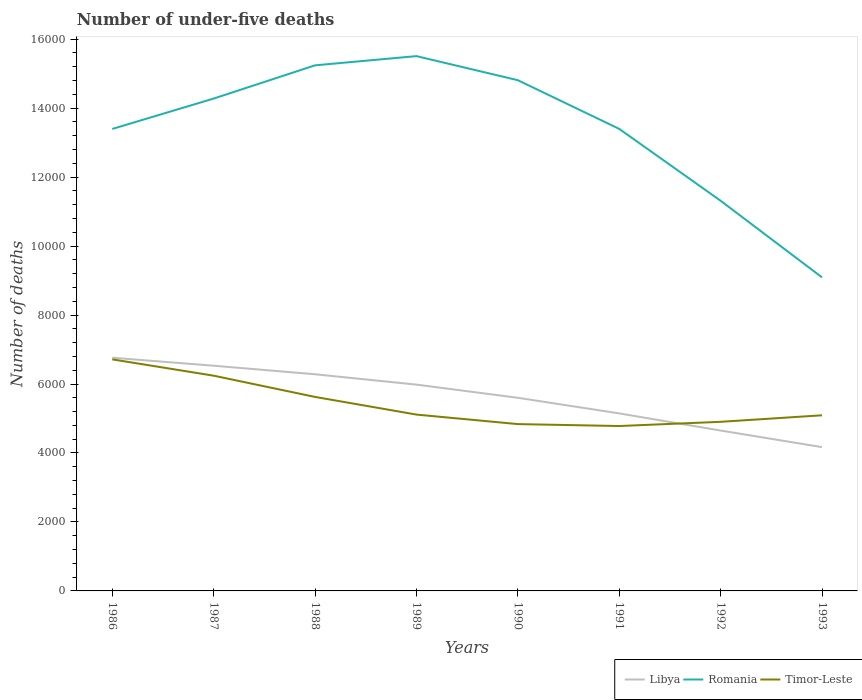Is the number of lines equal to the number of legend labels?
Your response must be concise. Yes. Across all years, what is the maximum number of under-five deaths in Timor-Leste?
Your response must be concise. 4782. What is the total number of under-five deaths in Romania in the graph?
Your response must be concise. 1843. What is the difference between the highest and the second highest number of under-five deaths in Timor-Leste?
Keep it short and to the point. 1933. What is the difference between the highest and the lowest number of under-five deaths in Libya?
Your answer should be very brief. 4. Is the number of under-five deaths in Timor-Leste strictly greater than the number of under-five deaths in Libya over the years?
Keep it short and to the point. No. How many lines are there?
Offer a terse response. 3. Are the values on the major ticks of Y-axis written in scientific E-notation?
Keep it short and to the point. No. Does the graph contain grids?
Your answer should be compact. No. How many legend labels are there?
Offer a terse response. 3. How are the legend labels stacked?
Offer a terse response. Horizontal. What is the title of the graph?
Give a very brief answer. Number of under-five deaths. Does "France" appear as one of the legend labels in the graph?
Keep it short and to the point. No. What is the label or title of the X-axis?
Ensure brevity in your answer.  Years. What is the label or title of the Y-axis?
Give a very brief answer. Number of deaths. What is the Number of deaths in Libya in 1986?
Make the answer very short. 6763. What is the Number of deaths of Romania in 1986?
Your response must be concise. 1.34e+04. What is the Number of deaths in Timor-Leste in 1986?
Provide a short and direct response. 6715. What is the Number of deaths in Libya in 1987?
Offer a terse response. 6531. What is the Number of deaths of Romania in 1987?
Your answer should be compact. 1.43e+04. What is the Number of deaths of Timor-Leste in 1987?
Provide a succinct answer. 6242. What is the Number of deaths in Libya in 1988?
Give a very brief answer. 6283. What is the Number of deaths of Romania in 1988?
Make the answer very short. 1.52e+04. What is the Number of deaths of Timor-Leste in 1988?
Ensure brevity in your answer.  5626. What is the Number of deaths in Libya in 1989?
Offer a terse response. 5983. What is the Number of deaths of Romania in 1989?
Provide a succinct answer. 1.55e+04. What is the Number of deaths of Timor-Leste in 1989?
Offer a very short reply. 5114. What is the Number of deaths in Libya in 1990?
Offer a terse response. 5601. What is the Number of deaths of Romania in 1990?
Keep it short and to the point. 1.48e+04. What is the Number of deaths in Timor-Leste in 1990?
Offer a very short reply. 4838. What is the Number of deaths of Libya in 1991?
Ensure brevity in your answer.  5148. What is the Number of deaths of Romania in 1991?
Ensure brevity in your answer.  1.34e+04. What is the Number of deaths of Timor-Leste in 1991?
Keep it short and to the point. 4782. What is the Number of deaths of Libya in 1992?
Provide a succinct answer. 4651. What is the Number of deaths of Romania in 1992?
Offer a very short reply. 1.13e+04. What is the Number of deaths of Timor-Leste in 1992?
Keep it short and to the point. 4904. What is the Number of deaths of Libya in 1993?
Your answer should be compact. 4170. What is the Number of deaths in Romania in 1993?
Your answer should be very brief. 9093. What is the Number of deaths of Timor-Leste in 1993?
Make the answer very short. 5093. Across all years, what is the maximum Number of deaths of Libya?
Keep it short and to the point. 6763. Across all years, what is the maximum Number of deaths in Romania?
Give a very brief answer. 1.55e+04. Across all years, what is the maximum Number of deaths of Timor-Leste?
Your answer should be compact. 6715. Across all years, what is the minimum Number of deaths of Libya?
Make the answer very short. 4170. Across all years, what is the minimum Number of deaths of Romania?
Your response must be concise. 9093. Across all years, what is the minimum Number of deaths in Timor-Leste?
Offer a very short reply. 4782. What is the total Number of deaths of Libya in the graph?
Offer a terse response. 4.51e+04. What is the total Number of deaths in Romania in the graph?
Ensure brevity in your answer.  1.07e+05. What is the total Number of deaths of Timor-Leste in the graph?
Your response must be concise. 4.33e+04. What is the difference between the Number of deaths in Libya in 1986 and that in 1987?
Your answer should be compact. 232. What is the difference between the Number of deaths of Romania in 1986 and that in 1987?
Make the answer very short. -881. What is the difference between the Number of deaths of Timor-Leste in 1986 and that in 1987?
Your answer should be compact. 473. What is the difference between the Number of deaths in Libya in 1986 and that in 1988?
Provide a short and direct response. 480. What is the difference between the Number of deaths in Romania in 1986 and that in 1988?
Make the answer very short. -1845. What is the difference between the Number of deaths in Timor-Leste in 1986 and that in 1988?
Provide a short and direct response. 1089. What is the difference between the Number of deaths in Libya in 1986 and that in 1989?
Give a very brief answer. 780. What is the difference between the Number of deaths in Romania in 1986 and that in 1989?
Ensure brevity in your answer.  -2112. What is the difference between the Number of deaths of Timor-Leste in 1986 and that in 1989?
Provide a short and direct response. 1601. What is the difference between the Number of deaths in Libya in 1986 and that in 1990?
Make the answer very short. 1162. What is the difference between the Number of deaths of Romania in 1986 and that in 1990?
Offer a terse response. -1414. What is the difference between the Number of deaths in Timor-Leste in 1986 and that in 1990?
Provide a succinct answer. 1877. What is the difference between the Number of deaths in Libya in 1986 and that in 1991?
Keep it short and to the point. 1615. What is the difference between the Number of deaths in Romania in 1986 and that in 1991?
Provide a succinct answer. -2. What is the difference between the Number of deaths of Timor-Leste in 1986 and that in 1991?
Ensure brevity in your answer.  1933. What is the difference between the Number of deaths of Libya in 1986 and that in 1992?
Keep it short and to the point. 2112. What is the difference between the Number of deaths of Romania in 1986 and that in 1992?
Provide a succinct answer. 2082. What is the difference between the Number of deaths in Timor-Leste in 1986 and that in 1992?
Your answer should be compact. 1811. What is the difference between the Number of deaths of Libya in 1986 and that in 1993?
Provide a succinct answer. 2593. What is the difference between the Number of deaths in Romania in 1986 and that in 1993?
Your answer should be compact. 4304. What is the difference between the Number of deaths in Timor-Leste in 1986 and that in 1993?
Keep it short and to the point. 1622. What is the difference between the Number of deaths of Libya in 1987 and that in 1988?
Your answer should be compact. 248. What is the difference between the Number of deaths in Romania in 1987 and that in 1988?
Your answer should be very brief. -964. What is the difference between the Number of deaths in Timor-Leste in 1987 and that in 1988?
Your response must be concise. 616. What is the difference between the Number of deaths of Libya in 1987 and that in 1989?
Offer a very short reply. 548. What is the difference between the Number of deaths of Romania in 1987 and that in 1989?
Provide a short and direct response. -1231. What is the difference between the Number of deaths of Timor-Leste in 1987 and that in 1989?
Offer a terse response. 1128. What is the difference between the Number of deaths of Libya in 1987 and that in 1990?
Your answer should be very brief. 930. What is the difference between the Number of deaths of Romania in 1987 and that in 1990?
Ensure brevity in your answer.  -533. What is the difference between the Number of deaths in Timor-Leste in 1987 and that in 1990?
Ensure brevity in your answer.  1404. What is the difference between the Number of deaths of Libya in 1987 and that in 1991?
Provide a succinct answer. 1383. What is the difference between the Number of deaths of Romania in 1987 and that in 1991?
Make the answer very short. 879. What is the difference between the Number of deaths in Timor-Leste in 1987 and that in 1991?
Give a very brief answer. 1460. What is the difference between the Number of deaths of Libya in 1987 and that in 1992?
Your answer should be compact. 1880. What is the difference between the Number of deaths of Romania in 1987 and that in 1992?
Your answer should be very brief. 2963. What is the difference between the Number of deaths of Timor-Leste in 1987 and that in 1992?
Offer a terse response. 1338. What is the difference between the Number of deaths in Libya in 1987 and that in 1993?
Provide a succinct answer. 2361. What is the difference between the Number of deaths in Romania in 1987 and that in 1993?
Provide a succinct answer. 5185. What is the difference between the Number of deaths in Timor-Leste in 1987 and that in 1993?
Your answer should be compact. 1149. What is the difference between the Number of deaths in Libya in 1988 and that in 1989?
Provide a succinct answer. 300. What is the difference between the Number of deaths in Romania in 1988 and that in 1989?
Offer a very short reply. -267. What is the difference between the Number of deaths of Timor-Leste in 1988 and that in 1989?
Give a very brief answer. 512. What is the difference between the Number of deaths of Libya in 1988 and that in 1990?
Offer a very short reply. 682. What is the difference between the Number of deaths of Romania in 1988 and that in 1990?
Ensure brevity in your answer.  431. What is the difference between the Number of deaths in Timor-Leste in 1988 and that in 1990?
Ensure brevity in your answer.  788. What is the difference between the Number of deaths of Libya in 1988 and that in 1991?
Provide a short and direct response. 1135. What is the difference between the Number of deaths in Romania in 1988 and that in 1991?
Ensure brevity in your answer.  1843. What is the difference between the Number of deaths of Timor-Leste in 1988 and that in 1991?
Give a very brief answer. 844. What is the difference between the Number of deaths in Libya in 1988 and that in 1992?
Your response must be concise. 1632. What is the difference between the Number of deaths of Romania in 1988 and that in 1992?
Provide a short and direct response. 3927. What is the difference between the Number of deaths in Timor-Leste in 1988 and that in 1992?
Offer a terse response. 722. What is the difference between the Number of deaths of Libya in 1988 and that in 1993?
Offer a terse response. 2113. What is the difference between the Number of deaths of Romania in 1988 and that in 1993?
Offer a terse response. 6149. What is the difference between the Number of deaths in Timor-Leste in 1988 and that in 1993?
Your response must be concise. 533. What is the difference between the Number of deaths in Libya in 1989 and that in 1990?
Offer a terse response. 382. What is the difference between the Number of deaths of Romania in 1989 and that in 1990?
Your answer should be very brief. 698. What is the difference between the Number of deaths in Timor-Leste in 1989 and that in 1990?
Your answer should be very brief. 276. What is the difference between the Number of deaths of Libya in 1989 and that in 1991?
Your answer should be compact. 835. What is the difference between the Number of deaths of Romania in 1989 and that in 1991?
Provide a succinct answer. 2110. What is the difference between the Number of deaths in Timor-Leste in 1989 and that in 1991?
Make the answer very short. 332. What is the difference between the Number of deaths in Libya in 1989 and that in 1992?
Your answer should be compact. 1332. What is the difference between the Number of deaths of Romania in 1989 and that in 1992?
Your answer should be very brief. 4194. What is the difference between the Number of deaths of Timor-Leste in 1989 and that in 1992?
Your answer should be very brief. 210. What is the difference between the Number of deaths of Libya in 1989 and that in 1993?
Offer a terse response. 1813. What is the difference between the Number of deaths of Romania in 1989 and that in 1993?
Offer a very short reply. 6416. What is the difference between the Number of deaths in Timor-Leste in 1989 and that in 1993?
Make the answer very short. 21. What is the difference between the Number of deaths of Libya in 1990 and that in 1991?
Ensure brevity in your answer.  453. What is the difference between the Number of deaths in Romania in 1990 and that in 1991?
Offer a terse response. 1412. What is the difference between the Number of deaths of Libya in 1990 and that in 1992?
Ensure brevity in your answer.  950. What is the difference between the Number of deaths of Romania in 1990 and that in 1992?
Make the answer very short. 3496. What is the difference between the Number of deaths of Timor-Leste in 1990 and that in 1992?
Provide a short and direct response. -66. What is the difference between the Number of deaths of Libya in 1990 and that in 1993?
Provide a short and direct response. 1431. What is the difference between the Number of deaths of Romania in 1990 and that in 1993?
Offer a very short reply. 5718. What is the difference between the Number of deaths in Timor-Leste in 1990 and that in 1993?
Offer a terse response. -255. What is the difference between the Number of deaths of Libya in 1991 and that in 1992?
Give a very brief answer. 497. What is the difference between the Number of deaths of Romania in 1991 and that in 1992?
Your response must be concise. 2084. What is the difference between the Number of deaths of Timor-Leste in 1991 and that in 1992?
Offer a very short reply. -122. What is the difference between the Number of deaths of Libya in 1991 and that in 1993?
Make the answer very short. 978. What is the difference between the Number of deaths in Romania in 1991 and that in 1993?
Keep it short and to the point. 4306. What is the difference between the Number of deaths of Timor-Leste in 1991 and that in 1993?
Offer a very short reply. -311. What is the difference between the Number of deaths in Libya in 1992 and that in 1993?
Your answer should be compact. 481. What is the difference between the Number of deaths of Romania in 1992 and that in 1993?
Make the answer very short. 2222. What is the difference between the Number of deaths in Timor-Leste in 1992 and that in 1993?
Ensure brevity in your answer.  -189. What is the difference between the Number of deaths of Libya in 1986 and the Number of deaths of Romania in 1987?
Your answer should be compact. -7515. What is the difference between the Number of deaths of Libya in 1986 and the Number of deaths of Timor-Leste in 1987?
Make the answer very short. 521. What is the difference between the Number of deaths of Romania in 1986 and the Number of deaths of Timor-Leste in 1987?
Give a very brief answer. 7155. What is the difference between the Number of deaths in Libya in 1986 and the Number of deaths in Romania in 1988?
Provide a succinct answer. -8479. What is the difference between the Number of deaths in Libya in 1986 and the Number of deaths in Timor-Leste in 1988?
Offer a very short reply. 1137. What is the difference between the Number of deaths in Romania in 1986 and the Number of deaths in Timor-Leste in 1988?
Offer a very short reply. 7771. What is the difference between the Number of deaths of Libya in 1986 and the Number of deaths of Romania in 1989?
Provide a succinct answer. -8746. What is the difference between the Number of deaths of Libya in 1986 and the Number of deaths of Timor-Leste in 1989?
Give a very brief answer. 1649. What is the difference between the Number of deaths of Romania in 1986 and the Number of deaths of Timor-Leste in 1989?
Offer a terse response. 8283. What is the difference between the Number of deaths of Libya in 1986 and the Number of deaths of Romania in 1990?
Give a very brief answer. -8048. What is the difference between the Number of deaths in Libya in 1986 and the Number of deaths in Timor-Leste in 1990?
Provide a succinct answer. 1925. What is the difference between the Number of deaths in Romania in 1986 and the Number of deaths in Timor-Leste in 1990?
Provide a short and direct response. 8559. What is the difference between the Number of deaths in Libya in 1986 and the Number of deaths in Romania in 1991?
Offer a very short reply. -6636. What is the difference between the Number of deaths in Libya in 1986 and the Number of deaths in Timor-Leste in 1991?
Your answer should be compact. 1981. What is the difference between the Number of deaths of Romania in 1986 and the Number of deaths of Timor-Leste in 1991?
Provide a short and direct response. 8615. What is the difference between the Number of deaths of Libya in 1986 and the Number of deaths of Romania in 1992?
Your answer should be compact. -4552. What is the difference between the Number of deaths in Libya in 1986 and the Number of deaths in Timor-Leste in 1992?
Offer a very short reply. 1859. What is the difference between the Number of deaths of Romania in 1986 and the Number of deaths of Timor-Leste in 1992?
Your response must be concise. 8493. What is the difference between the Number of deaths in Libya in 1986 and the Number of deaths in Romania in 1993?
Give a very brief answer. -2330. What is the difference between the Number of deaths in Libya in 1986 and the Number of deaths in Timor-Leste in 1993?
Offer a very short reply. 1670. What is the difference between the Number of deaths in Romania in 1986 and the Number of deaths in Timor-Leste in 1993?
Give a very brief answer. 8304. What is the difference between the Number of deaths in Libya in 1987 and the Number of deaths in Romania in 1988?
Keep it short and to the point. -8711. What is the difference between the Number of deaths in Libya in 1987 and the Number of deaths in Timor-Leste in 1988?
Your answer should be very brief. 905. What is the difference between the Number of deaths of Romania in 1987 and the Number of deaths of Timor-Leste in 1988?
Your response must be concise. 8652. What is the difference between the Number of deaths in Libya in 1987 and the Number of deaths in Romania in 1989?
Your answer should be compact. -8978. What is the difference between the Number of deaths of Libya in 1987 and the Number of deaths of Timor-Leste in 1989?
Give a very brief answer. 1417. What is the difference between the Number of deaths in Romania in 1987 and the Number of deaths in Timor-Leste in 1989?
Give a very brief answer. 9164. What is the difference between the Number of deaths of Libya in 1987 and the Number of deaths of Romania in 1990?
Offer a very short reply. -8280. What is the difference between the Number of deaths in Libya in 1987 and the Number of deaths in Timor-Leste in 1990?
Offer a very short reply. 1693. What is the difference between the Number of deaths in Romania in 1987 and the Number of deaths in Timor-Leste in 1990?
Keep it short and to the point. 9440. What is the difference between the Number of deaths of Libya in 1987 and the Number of deaths of Romania in 1991?
Your answer should be very brief. -6868. What is the difference between the Number of deaths of Libya in 1987 and the Number of deaths of Timor-Leste in 1991?
Give a very brief answer. 1749. What is the difference between the Number of deaths in Romania in 1987 and the Number of deaths in Timor-Leste in 1991?
Make the answer very short. 9496. What is the difference between the Number of deaths in Libya in 1987 and the Number of deaths in Romania in 1992?
Offer a terse response. -4784. What is the difference between the Number of deaths in Libya in 1987 and the Number of deaths in Timor-Leste in 1992?
Give a very brief answer. 1627. What is the difference between the Number of deaths of Romania in 1987 and the Number of deaths of Timor-Leste in 1992?
Your answer should be compact. 9374. What is the difference between the Number of deaths of Libya in 1987 and the Number of deaths of Romania in 1993?
Provide a succinct answer. -2562. What is the difference between the Number of deaths of Libya in 1987 and the Number of deaths of Timor-Leste in 1993?
Keep it short and to the point. 1438. What is the difference between the Number of deaths in Romania in 1987 and the Number of deaths in Timor-Leste in 1993?
Keep it short and to the point. 9185. What is the difference between the Number of deaths of Libya in 1988 and the Number of deaths of Romania in 1989?
Provide a short and direct response. -9226. What is the difference between the Number of deaths in Libya in 1988 and the Number of deaths in Timor-Leste in 1989?
Offer a very short reply. 1169. What is the difference between the Number of deaths of Romania in 1988 and the Number of deaths of Timor-Leste in 1989?
Keep it short and to the point. 1.01e+04. What is the difference between the Number of deaths in Libya in 1988 and the Number of deaths in Romania in 1990?
Your answer should be very brief. -8528. What is the difference between the Number of deaths in Libya in 1988 and the Number of deaths in Timor-Leste in 1990?
Keep it short and to the point. 1445. What is the difference between the Number of deaths in Romania in 1988 and the Number of deaths in Timor-Leste in 1990?
Your response must be concise. 1.04e+04. What is the difference between the Number of deaths in Libya in 1988 and the Number of deaths in Romania in 1991?
Your answer should be very brief. -7116. What is the difference between the Number of deaths in Libya in 1988 and the Number of deaths in Timor-Leste in 1991?
Make the answer very short. 1501. What is the difference between the Number of deaths of Romania in 1988 and the Number of deaths of Timor-Leste in 1991?
Give a very brief answer. 1.05e+04. What is the difference between the Number of deaths of Libya in 1988 and the Number of deaths of Romania in 1992?
Offer a very short reply. -5032. What is the difference between the Number of deaths of Libya in 1988 and the Number of deaths of Timor-Leste in 1992?
Give a very brief answer. 1379. What is the difference between the Number of deaths of Romania in 1988 and the Number of deaths of Timor-Leste in 1992?
Keep it short and to the point. 1.03e+04. What is the difference between the Number of deaths in Libya in 1988 and the Number of deaths in Romania in 1993?
Your answer should be very brief. -2810. What is the difference between the Number of deaths of Libya in 1988 and the Number of deaths of Timor-Leste in 1993?
Provide a succinct answer. 1190. What is the difference between the Number of deaths in Romania in 1988 and the Number of deaths in Timor-Leste in 1993?
Make the answer very short. 1.01e+04. What is the difference between the Number of deaths of Libya in 1989 and the Number of deaths of Romania in 1990?
Your answer should be very brief. -8828. What is the difference between the Number of deaths in Libya in 1989 and the Number of deaths in Timor-Leste in 1990?
Provide a short and direct response. 1145. What is the difference between the Number of deaths of Romania in 1989 and the Number of deaths of Timor-Leste in 1990?
Make the answer very short. 1.07e+04. What is the difference between the Number of deaths in Libya in 1989 and the Number of deaths in Romania in 1991?
Provide a succinct answer. -7416. What is the difference between the Number of deaths in Libya in 1989 and the Number of deaths in Timor-Leste in 1991?
Your answer should be very brief. 1201. What is the difference between the Number of deaths of Romania in 1989 and the Number of deaths of Timor-Leste in 1991?
Your answer should be very brief. 1.07e+04. What is the difference between the Number of deaths in Libya in 1989 and the Number of deaths in Romania in 1992?
Your answer should be compact. -5332. What is the difference between the Number of deaths of Libya in 1989 and the Number of deaths of Timor-Leste in 1992?
Offer a very short reply. 1079. What is the difference between the Number of deaths of Romania in 1989 and the Number of deaths of Timor-Leste in 1992?
Ensure brevity in your answer.  1.06e+04. What is the difference between the Number of deaths of Libya in 1989 and the Number of deaths of Romania in 1993?
Provide a succinct answer. -3110. What is the difference between the Number of deaths in Libya in 1989 and the Number of deaths in Timor-Leste in 1993?
Make the answer very short. 890. What is the difference between the Number of deaths of Romania in 1989 and the Number of deaths of Timor-Leste in 1993?
Keep it short and to the point. 1.04e+04. What is the difference between the Number of deaths of Libya in 1990 and the Number of deaths of Romania in 1991?
Offer a terse response. -7798. What is the difference between the Number of deaths of Libya in 1990 and the Number of deaths of Timor-Leste in 1991?
Ensure brevity in your answer.  819. What is the difference between the Number of deaths of Romania in 1990 and the Number of deaths of Timor-Leste in 1991?
Provide a short and direct response. 1.00e+04. What is the difference between the Number of deaths of Libya in 1990 and the Number of deaths of Romania in 1992?
Provide a succinct answer. -5714. What is the difference between the Number of deaths of Libya in 1990 and the Number of deaths of Timor-Leste in 1992?
Offer a terse response. 697. What is the difference between the Number of deaths in Romania in 1990 and the Number of deaths in Timor-Leste in 1992?
Ensure brevity in your answer.  9907. What is the difference between the Number of deaths in Libya in 1990 and the Number of deaths in Romania in 1993?
Ensure brevity in your answer.  -3492. What is the difference between the Number of deaths of Libya in 1990 and the Number of deaths of Timor-Leste in 1993?
Make the answer very short. 508. What is the difference between the Number of deaths of Romania in 1990 and the Number of deaths of Timor-Leste in 1993?
Give a very brief answer. 9718. What is the difference between the Number of deaths in Libya in 1991 and the Number of deaths in Romania in 1992?
Offer a terse response. -6167. What is the difference between the Number of deaths of Libya in 1991 and the Number of deaths of Timor-Leste in 1992?
Your answer should be compact. 244. What is the difference between the Number of deaths in Romania in 1991 and the Number of deaths in Timor-Leste in 1992?
Provide a succinct answer. 8495. What is the difference between the Number of deaths of Libya in 1991 and the Number of deaths of Romania in 1993?
Provide a succinct answer. -3945. What is the difference between the Number of deaths in Libya in 1991 and the Number of deaths in Timor-Leste in 1993?
Your response must be concise. 55. What is the difference between the Number of deaths of Romania in 1991 and the Number of deaths of Timor-Leste in 1993?
Your answer should be compact. 8306. What is the difference between the Number of deaths in Libya in 1992 and the Number of deaths in Romania in 1993?
Make the answer very short. -4442. What is the difference between the Number of deaths of Libya in 1992 and the Number of deaths of Timor-Leste in 1993?
Your answer should be compact. -442. What is the difference between the Number of deaths in Romania in 1992 and the Number of deaths in Timor-Leste in 1993?
Provide a succinct answer. 6222. What is the average Number of deaths of Libya per year?
Keep it short and to the point. 5641.25. What is the average Number of deaths of Romania per year?
Your answer should be compact. 1.34e+04. What is the average Number of deaths in Timor-Leste per year?
Keep it short and to the point. 5414.25. In the year 1986, what is the difference between the Number of deaths of Libya and Number of deaths of Romania?
Your answer should be compact. -6634. In the year 1986, what is the difference between the Number of deaths of Libya and Number of deaths of Timor-Leste?
Your answer should be compact. 48. In the year 1986, what is the difference between the Number of deaths of Romania and Number of deaths of Timor-Leste?
Your answer should be compact. 6682. In the year 1987, what is the difference between the Number of deaths in Libya and Number of deaths in Romania?
Ensure brevity in your answer.  -7747. In the year 1987, what is the difference between the Number of deaths of Libya and Number of deaths of Timor-Leste?
Give a very brief answer. 289. In the year 1987, what is the difference between the Number of deaths of Romania and Number of deaths of Timor-Leste?
Provide a short and direct response. 8036. In the year 1988, what is the difference between the Number of deaths of Libya and Number of deaths of Romania?
Your answer should be compact. -8959. In the year 1988, what is the difference between the Number of deaths in Libya and Number of deaths in Timor-Leste?
Provide a short and direct response. 657. In the year 1988, what is the difference between the Number of deaths in Romania and Number of deaths in Timor-Leste?
Your answer should be very brief. 9616. In the year 1989, what is the difference between the Number of deaths of Libya and Number of deaths of Romania?
Give a very brief answer. -9526. In the year 1989, what is the difference between the Number of deaths in Libya and Number of deaths in Timor-Leste?
Keep it short and to the point. 869. In the year 1989, what is the difference between the Number of deaths in Romania and Number of deaths in Timor-Leste?
Provide a succinct answer. 1.04e+04. In the year 1990, what is the difference between the Number of deaths in Libya and Number of deaths in Romania?
Keep it short and to the point. -9210. In the year 1990, what is the difference between the Number of deaths of Libya and Number of deaths of Timor-Leste?
Your answer should be compact. 763. In the year 1990, what is the difference between the Number of deaths of Romania and Number of deaths of Timor-Leste?
Keep it short and to the point. 9973. In the year 1991, what is the difference between the Number of deaths of Libya and Number of deaths of Romania?
Ensure brevity in your answer.  -8251. In the year 1991, what is the difference between the Number of deaths of Libya and Number of deaths of Timor-Leste?
Ensure brevity in your answer.  366. In the year 1991, what is the difference between the Number of deaths of Romania and Number of deaths of Timor-Leste?
Offer a very short reply. 8617. In the year 1992, what is the difference between the Number of deaths in Libya and Number of deaths in Romania?
Provide a short and direct response. -6664. In the year 1992, what is the difference between the Number of deaths of Libya and Number of deaths of Timor-Leste?
Provide a succinct answer. -253. In the year 1992, what is the difference between the Number of deaths in Romania and Number of deaths in Timor-Leste?
Your answer should be compact. 6411. In the year 1993, what is the difference between the Number of deaths in Libya and Number of deaths in Romania?
Keep it short and to the point. -4923. In the year 1993, what is the difference between the Number of deaths of Libya and Number of deaths of Timor-Leste?
Offer a very short reply. -923. In the year 1993, what is the difference between the Number of deaths of Romania and Number of deaths of Timor-Leste?
Give a very brief answer. 4000. What is the ratio of the Number of deaths of Libya in 1986 to that in 1987?
Your answer should be compact. 1.04. What is the ratio of the Number of deaths in Romania in 1986 to that in 1987?
Your answer should be compact. 0.94. What is the ratio of the Number of deaths in Timor-Leste in 1986 to that in 1987?
Offer a very short reply. 1.08. What is the ratio of the Number of deaths of Libya in 1986 to that in 1988?
Make the answer very short. 1.08. What is the ratio of the Number of deaths in Romania in 1986 to that in 1988?
Provide a succinct answer. 0.88. What is the ratio of the Number of deaths in Timor-Leste in 1986 to that in 1988?
Provide a succinct answer. 1.19. What is the ratio of the Number of deaths in Libya in 1986 to that in 1989?
Offer a terse response. 1.13. What is the ratio of the Number of deaths of Romania in 1986 to that in 1989?
Your answer should be very brief. 0.86. What is the ratio of the Number of deaths of Timor-Leste in 1986 to that in 1989?
Offer a very short reply. 1.31. What is the ratio of the Number of deaths of Libya in 1986 to that in 1990?
Provide a succinct answer. 1.21. What is the ratio of the Number of deaths in Romania in 1986 to that in 1990?
Your answer should be compact. 0.9. What is the ratio of the Number of deaths in Timor-Leste in 1986 to that in 1990?
Keep it short and to the point. 1.39. What is the ratio of the Number of deaths in Libya in 1986 to that in 1991?
Offer a very short reply. 1.31. What is the ratio of the Number of deaths in Timor-Leste in 1986 to that in 1991?
Give a very brief answer. 1.4. What is the ratio of the Number of deaths of Libya in 1986 to that in 1992?
Give a very brief answer. 1.45. What is the ratio of the Number of deaths in Romania in 1986 to that in 1992?
Your answer should be very brief. 1.18. What is the ratio of the Number of deaths in Timor-Leste in 1986 to that in 1992?
Give a very brief answer. 1.37. What is the ratio of the Number of deaths in Libya in 1986 to that in 1993?
Make the answer very short. 1.62. What is the ratio of the Number of deaths in Romania in 1986 to that in 1993?
Make the answer very short. 1.47. What is the ratio of the Number of deaths in Timor-Leste in 1986 to that in 1993?
Your answer should be very brief. 1.32. What is the ratio of the Number of deaths in Libya in 1987 to that in 1988?
Your answer should be compact. 1.04. What is the ratio of the Number of deaths of Romania in 1987 to that in 1988?
Provide a short and direct response. 0.94. What is the ratio of the Number of deaths in Timor-Leste in 1987 to that in 1988?
Provide a short and direct response. 1.11. What is the ratio of the Number of deaths in Libya in 1987 to that in 1989?
Your response must be concise. 1.09. What is the ratio of the Number of deaths of Romania in 1987 to that in 1989?
Keep it short and to the point. 0.92. What is the ratio of the Number of deaths of Timor-Leste in 1987 to that in 1989?
Keep it short and to the point. 1.22. What is the ratio of the Number of deaths of Libya in 1987 to that in 1990?
Offer a terse response. 1.17. What is the ratio of the Number of deaths in Timor-Leste in 1987 to that in 1990?
Provide a succinct answer. 1.29. What is the ratio of the Number of deaths in Libya in 1987 to that in 1991?
Keep it short and to the point. 1.27. What is the ratio of the Number of deaths of Romania in 1987 to that in 1991?
Make the answer very short. 1.07. What is the ratio of the Number of deaths of Timor-Leste in 1987 to that in 1991?
Provide a succinct answer. 1.31. What is the ratio of the Number of deaths in Libya in 1987 to that in 1992?
Give a very brief answer. 1.4. What is the ratio of the Number of deaths of Romania in 1987 to that in 1992?
Offer a terse response. 1.26. What is the ratio of the Number of deaths of Timor-Leste in 1987 to that in 1992?
Keep it short and to the point. 1.27. What is the ratio of the Number of deaths in Libya in 1987 to that in 1993?
Provide a short and direct response. 1.57. What is the ratio of the Number of deaths of Romania in 1987 to that in 1993?
Your answer should be very brief. 1.57. What is the ratio of the Number of deaths of Timor-Leste in 1987 to that in 1993?
Your answer should be very brief. 1.23. What is the ratio of the Number of deaths of Libya in 1988 to that in 1989?
Give a very brief answer. 1.05. What is the ratio of the Number of deaths of Romania in 1988 to that in 1989?
Make the answer very short. 0.98. What is the ratio of the Number of deaths in Timor-Leste in 1988 to that in 1989?
Your answer should be compact. 1.1. What is the ratio of the Number of deaths in Libya in 1988 to that in 1990?
Ensure brevity in your answer.  1.12. What is the ratio of the Number of deaths in Romania in 1988 to that in 1990?
Make the answer very short. 1.03. What is the ratio of the Number of deaths in Timor-Leste in 1988 to that in 1990?
Keep it short and to the point. 1.16. What is the ratio of the Number of deaths of Libya in 1988 to that in 1991?
Offer a very short reply. 1.22. What is the ratio of the Number of deaths of Romania in 1988 to that in 1991?
Make the answer very short. 1.14. What is the ratio of the Number of deaths of Timor-Leste in 1988 to that in 1991?
Offer a very short reply. 1.18. What is the ratio of the Number of deaths in Libya in 1988 to that in 1992?
Offer a terse response. 1.35. What is the ratio of the Number of deaths of Romania in 1988 to that in 1992?
Your answer should be compact. 1.35. What is the ratio of the Number of deaths in Timor-Leste in 1988 to that in 1992?
Make the answer very short. 1.15. What is the ratio of the Number of deaths in Libya in 1988 to that in 1993?
Your answer should be very brief. 1.51. What is the ratio of the Number of deaths in Romania in 1988 to that in 1993?
Ensure brevity in your answer.  1.68. What is the ratio of the Number of deaths in Timor-Leste in 1988 to that in 1993?
Your response must be concise. 1.1. What is the ratio of the Number of deaths of Libya in 1989 to that in 1990?
Keep it short and to the point. 1.07. What is the ratio of the Number of deaths of Romania in 1989 to that in 1990?
Make the answer very short. 1.05. What is the ratio of the Number of deaths of Timor-Leste in 1989 to that in 1990?
Your answer should be very brief. 1.06. What is the ratio of the Number of deaths of Libya in 1989 to that in 1991?
Your response must be concise. 1.16. What is the ratio of the Number of deaths of Romania in 1989 to that in 1991?
Provide a succinct answer. 1.16. What is the ratio of the Number of deaths in Timor-Leste in 1989 to that in 1991?
Offer a very short reply. 1.07. What is the ratio of the Number of deaths of Libya in 1989 to that in 1992?
Your answer should be very brief. 1.29. What is the ratio of the Number of deaths of Romania in 1989 to that in 1992?
Your answer should be compact. 1.37. What is the ratio of the Number of deaths of Timor-Leste in 1989 to that in 1992?
Provide a short and direct response. 1.04. What is the ratio of the Number of deaths of Libya in 1989 to that in 1993?
Your response must be concise. 1.43. What is the ratio of the Number of deaths of Romania in 1989 to that in 1993?
Your response must be concise. 1.71. What is the ratio of the Number of deaths of Timor-Leste in 1989 to that in 1993?
Your answer should be compact. 1. What is the ratio of the Number of deaths in Libya in 1990 to that in 1991?
Offer a terse response. 1.09. What is the ratio of the Number of deaths of Romania in 1990 to that in 1991?
Your response must be concise. 1.11. What is the ratio of the Number of deaths of Timor-Leste in 1990 to that in 1991?
Your answer should be very brief. 1.01. What is the ratio of the Number of deaths of Libya in 1990 to that in 1992?
Give a very brief answer. 1.2. What is the ratio of the Number of deaths of Romania in 1990 to that in 1992?
Keep it short and to the point. 1.31. What is the ratio of the Number of deaths of Timor-Leste in 1990 to that in 1992?
Offer a very short reply. 0.99. What is the ratio of the Number of deaths of Libya in 1990 to that in 1993?
Ensure brevity in your answer.  1.34. What is the ratio of the Number of deaths of Romania in 1990 to that in 1993?
Offer a terse response. 1.63. What is the ratio of the Number of deaths in Timor-Leste in 1990 to that in 1993?
Provide a succinct answer. 0.95. What is the ratio of the Number of deaths in Libya in 1991 to that in 1992?
Provide a short and direct response. 1.11. What is the ratio of the Number of deaths of Romania in 1991 to that in 1992?
Ensure brevity in your answer.  1.18. What is the ratio of the Number of deaths of Timor-Leste in 1991 to that in 1992?
Keep it short and to the point. 0.98. What is the ratio of the Number of deaths in Libya in 1991 to that in 1993?
Offer a very short reply. 1.23. What is the ratio of the Number of deaths in Romania in 1991 to that in 1993?
Give a very brief answer. 1.47. What is the ratio of the Number of deaths in Timor-Leste in 1991 to that in 1993?
Offer a terse response. 0.94. What is the ratio of the Number of deaths in Libya in 1992 to that in 1993?
Your answer should be compact. 1.12. What is the ratio of the Number of deaths of Romania in 1992 to that in 1993?
Keep it short and to the point. 1.24. What is the ratio of the Number of deaths of Timor-Leste in 1992 to that in 1993?
Your response must be concise. 0.96. What is the difference between the highest and the second highest Number of deaths of Libya?
Your response must be concise. 232. What is the difference between the highest and the second highest Number of deaths in Romania?
Offer a very short reply. 267. What is the difference between the highest and the second highest Number of deaths in Timor-Leste?
Keep it short and to the point. 473. What is the difference between the highest and the lowest Number of deaths in Libya?
Your response must be concise. 2593. What is the difference between the highest and the lowest Number of deaths of Romania?
Provide a short and direct response. 6416. What is the difference between the highest and the lowest Number of deaths of Timor-Leste?
Offer a terse response. 1933. 